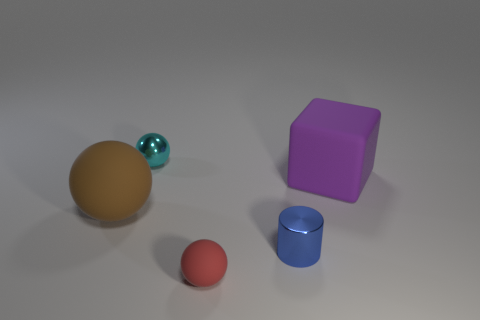Add 1 spheres. How many objects exist? 6 Subtract all cyan spheres. How many spheres are left? 2 Subtract all cubes. How many objects are left? 4 Subtract all red balls. How many yellow cylinders are left? 0 Subtract all large rubber spheres. Subtract all small cyan metallic things. How many objects are left? 3 Add 2 large brown rubber things. How many large brown rubber things are left? 3 Add 3 green metallic balls. How many green metallic balls exist? 3 Subtract 0 red blocks. How many objects are left? 5 Subtract 1 spheres. How many spheres are left? 2 Subtract all cyan blocks. Subtract all yellow spheres. How many blocks are left? 1 